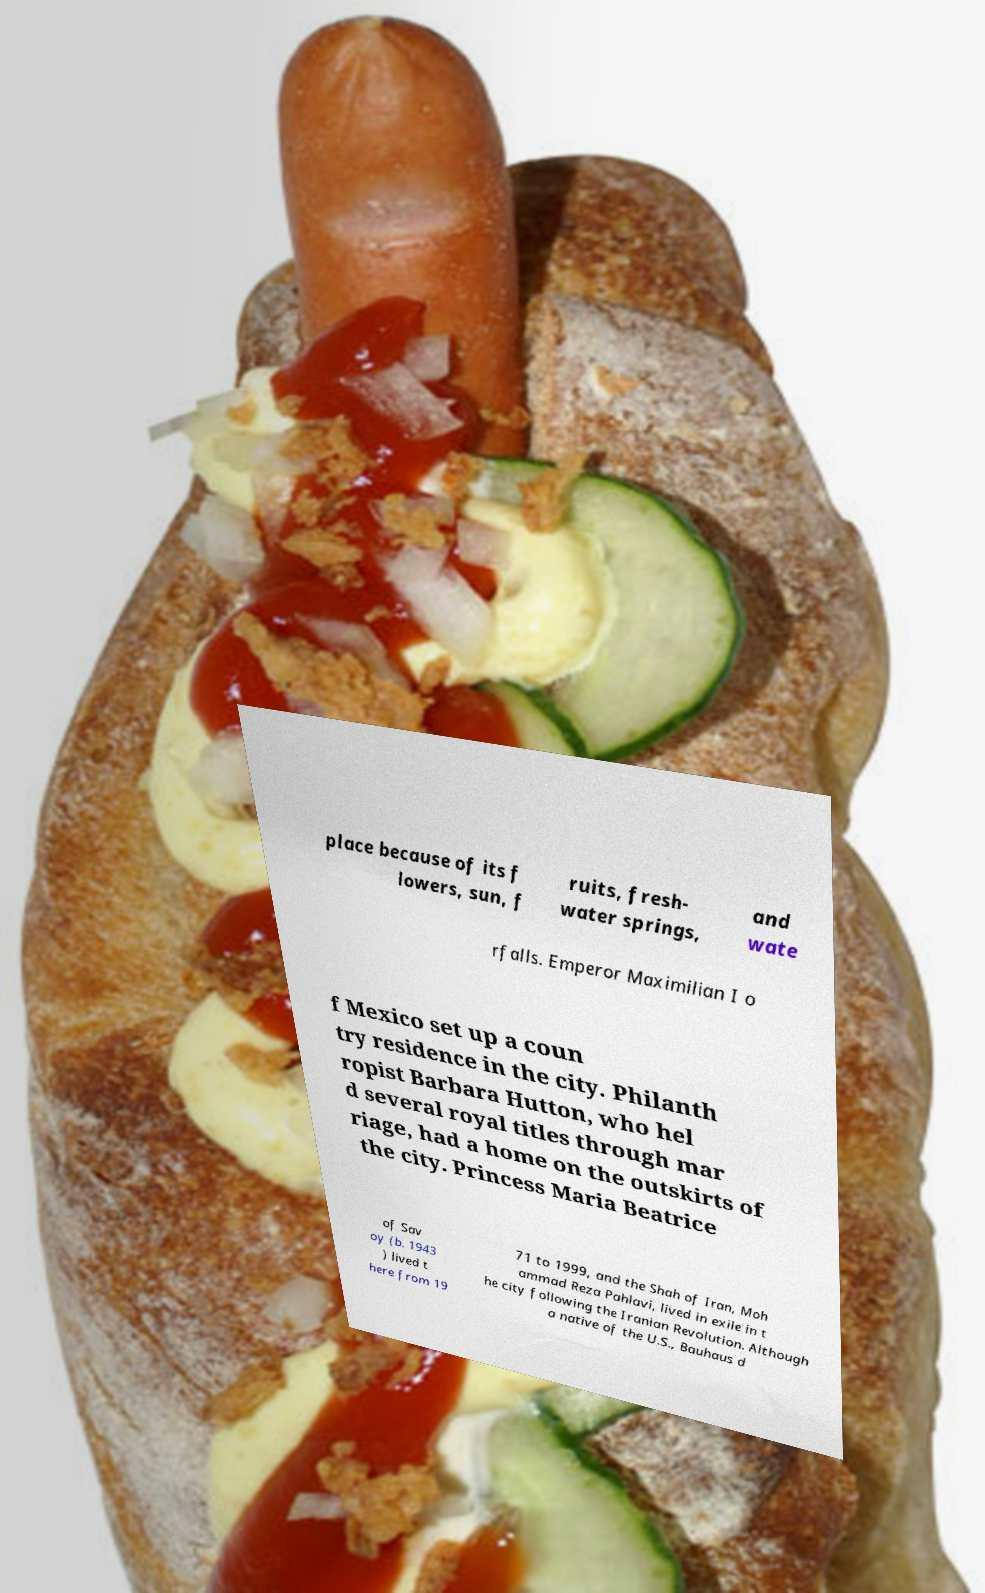Can you accurately transcribe the text from the provided image for me? place because of its f lowers, sun, f ruits, fresh- water springs, and wate rfalls. Emperor Maximilian I o f Mexico set up a coun try residence in the city. Philanth ropist Barbara Hutton, who hel d several royal titles through mar riage, had a home on the outskirts of the city. Princess Maria Beatrice of Sav oy (b. 1943 ) lived t here from 19 71 to 1999, and the Shah of Iran, Moh ammad Reza Pahlavi, lived in exile in t he city following the Iranian Revolution. Although a native of the U.S., Bauhaus d 